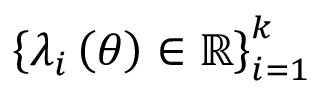<formula> <loc_0><loc_0><loc_500><loc_500>\left \{ \lambda _ { i } \left ( \theta \right ) \in \mathbb { R } \right \} _ { i = 1 } ^ { k }</formula> 